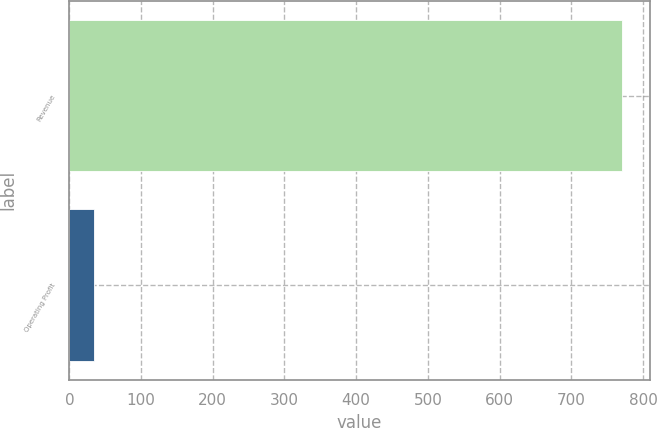<chart> <loc_0><loc_0><loc_500><loc_500><bar_chart><fcel>Revenue<fcel>Operating Profit<nl><fcel>770.6<fcel>34<nl></chart> 